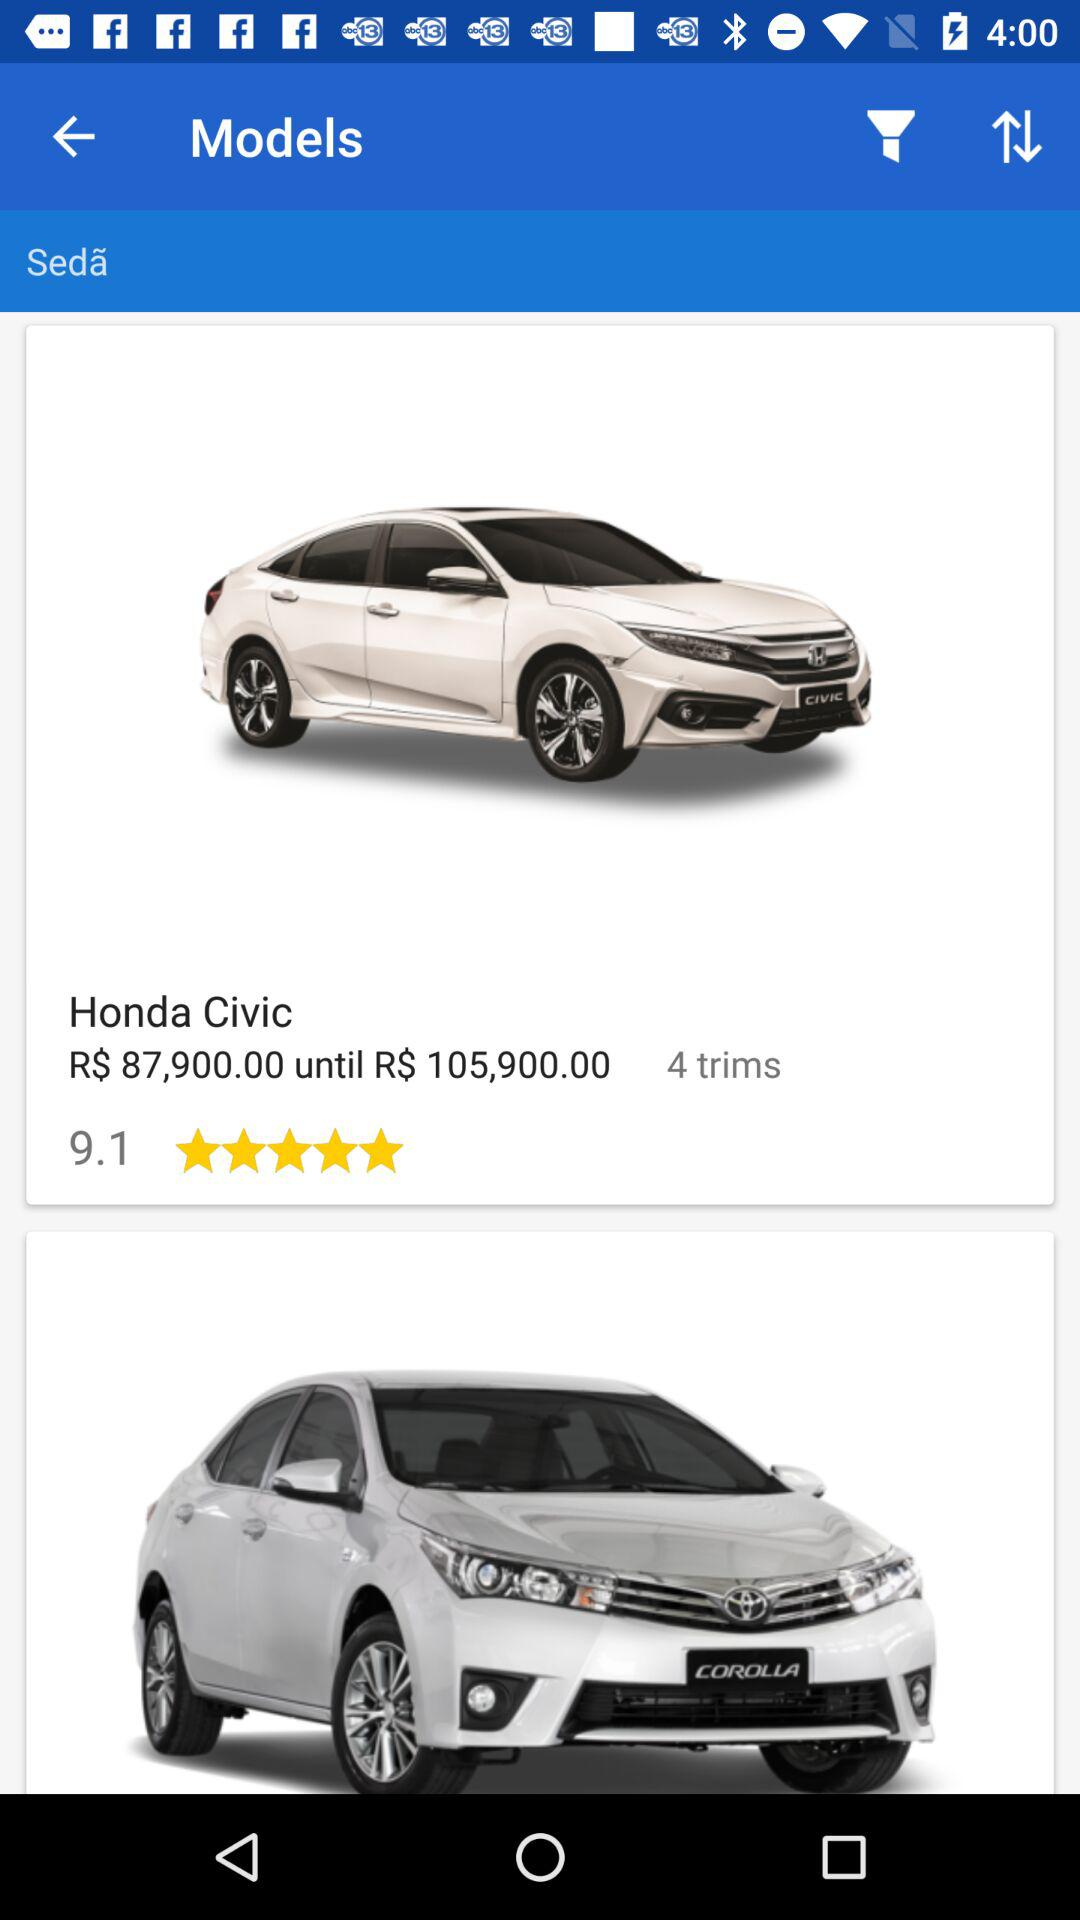What is the price range? The price ranges from R$87,900.00 to R$105,900.00. 